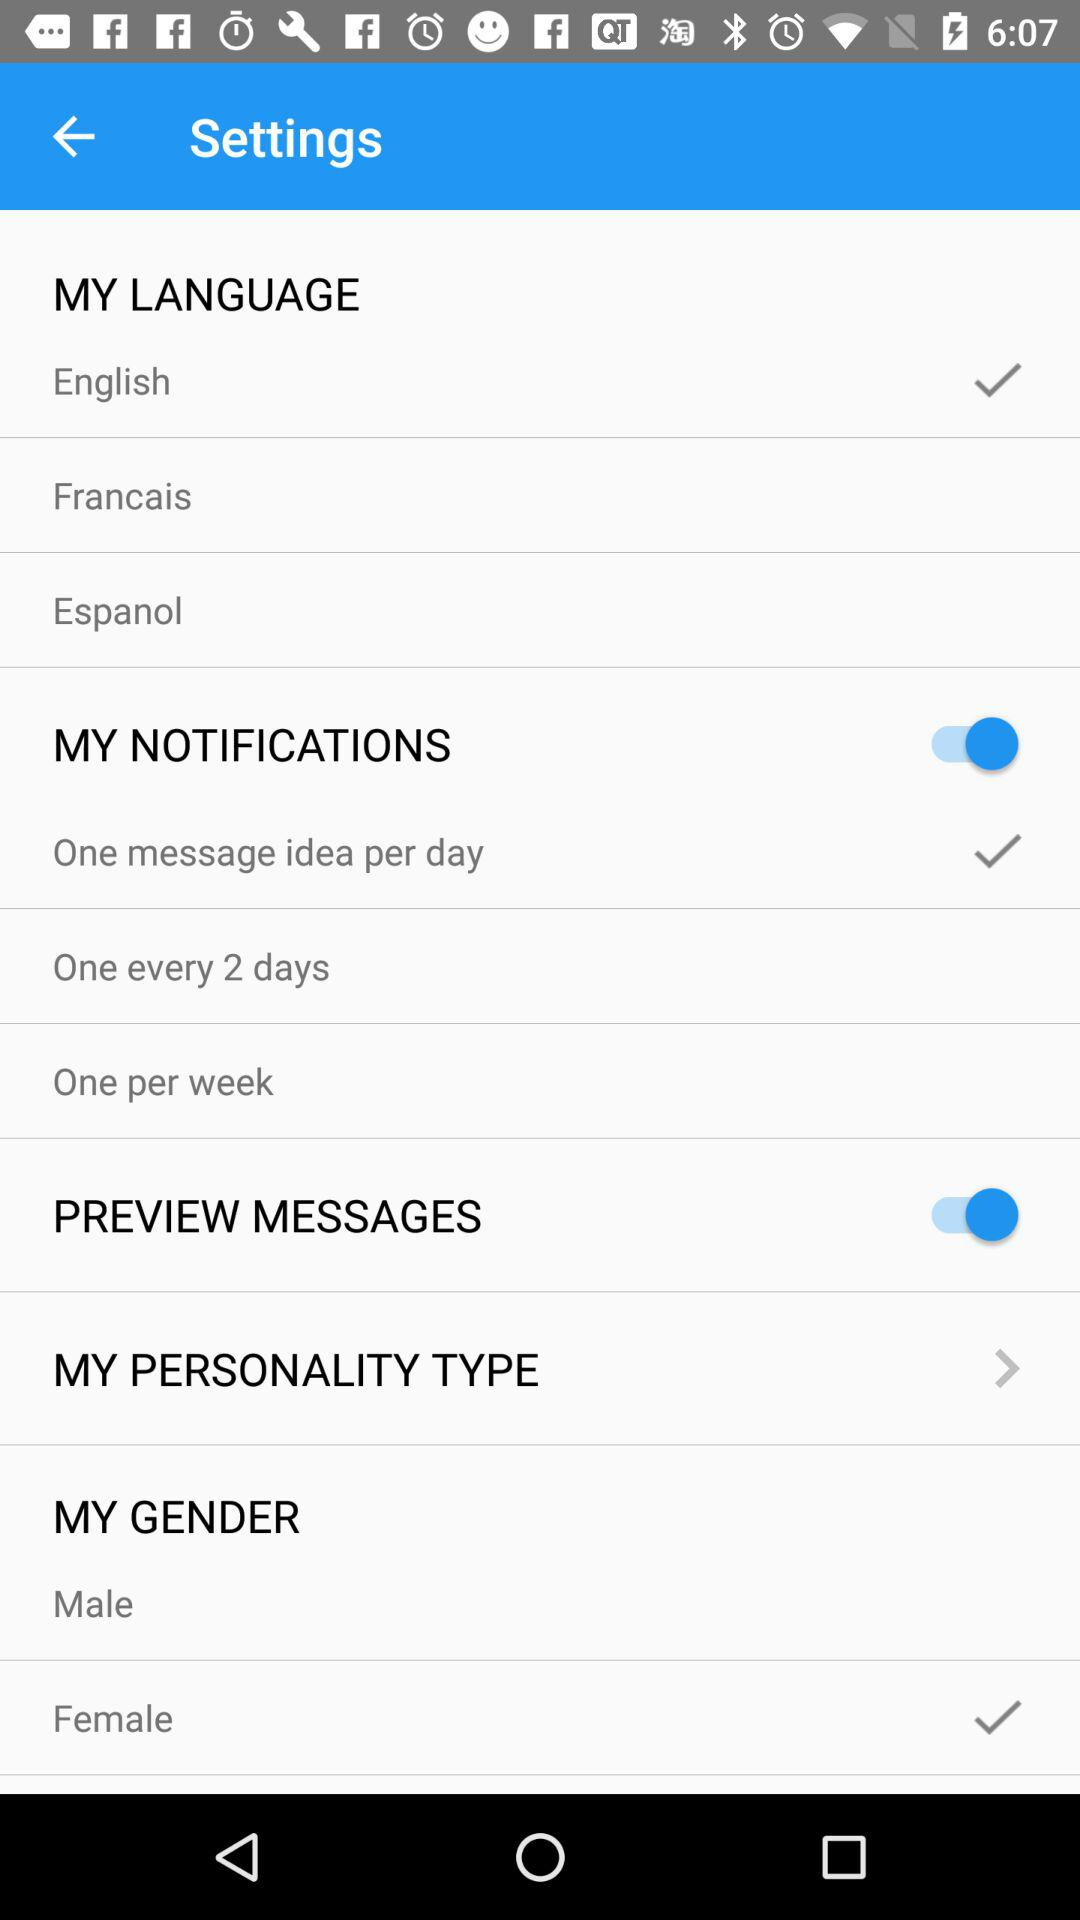What is the status of "MY NOTIFICATIONS"? The status of "MY NOTIFICATIONS" is "on". 